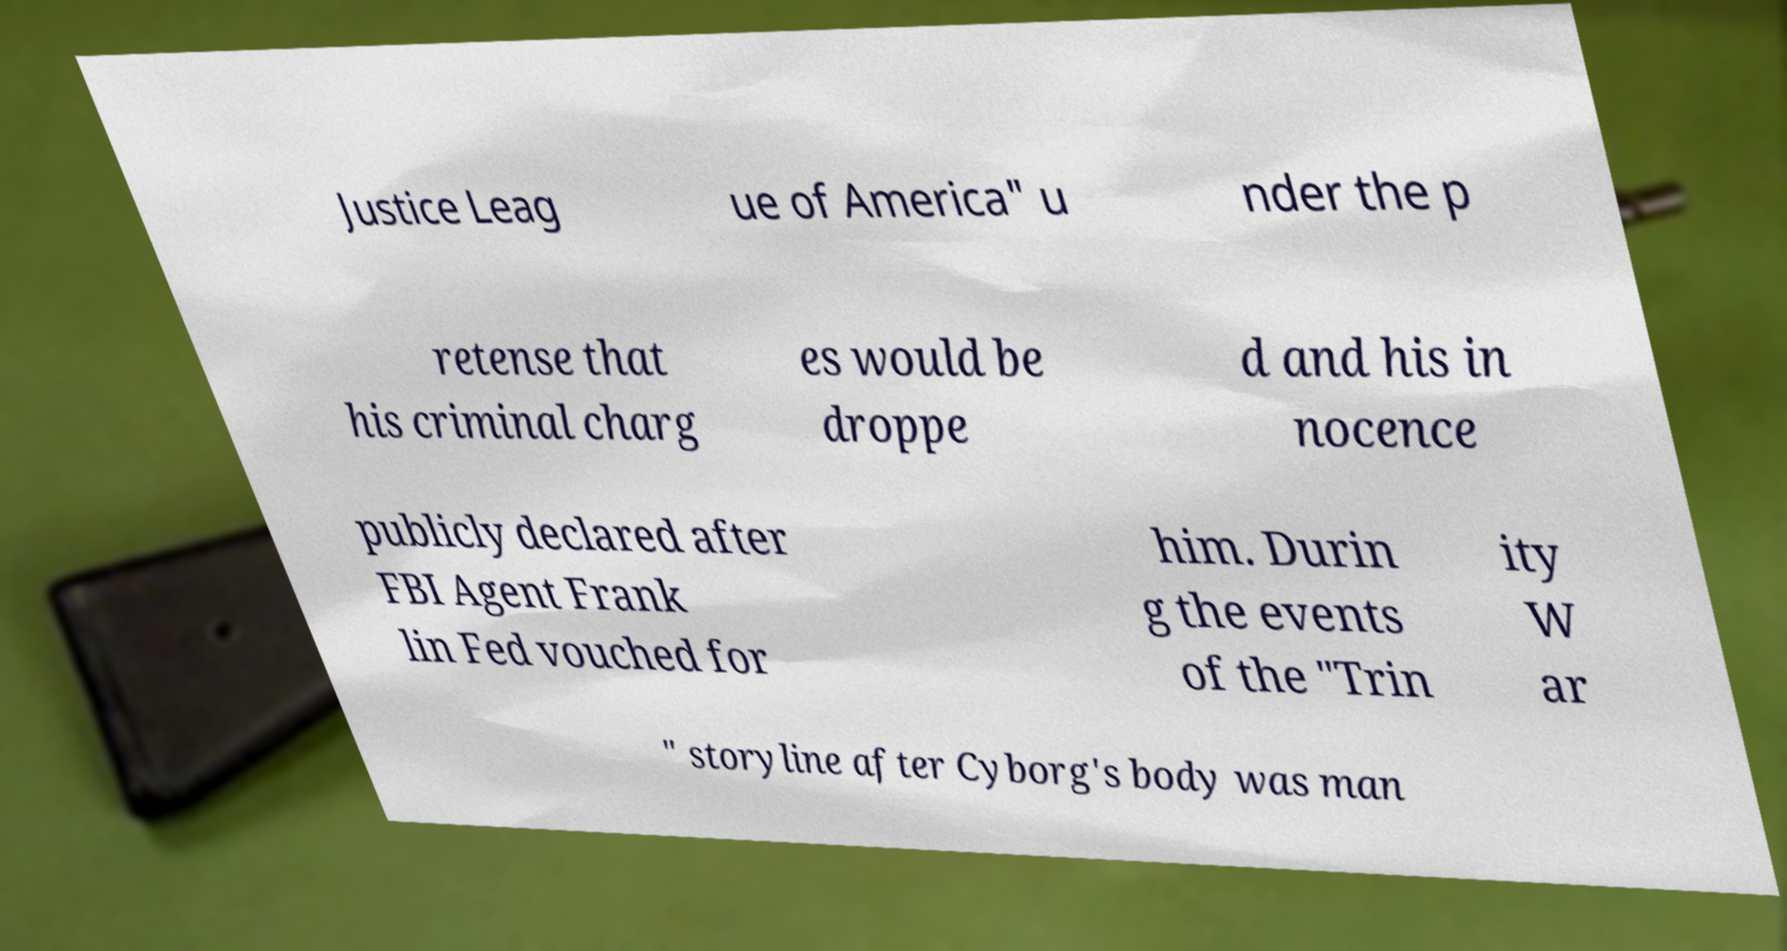There's text embedded in this image that I need extracted. Can you transcribe it verbatim? Justice Leag ue of America" u nder the p retense that his criminal charg es would be droppe d and his in nocence publicly declared after FBI Agent Frank lin Fed vouched for him. Durin g the events of the "Trin ity W ar " storyline after Cyborg's body was man 